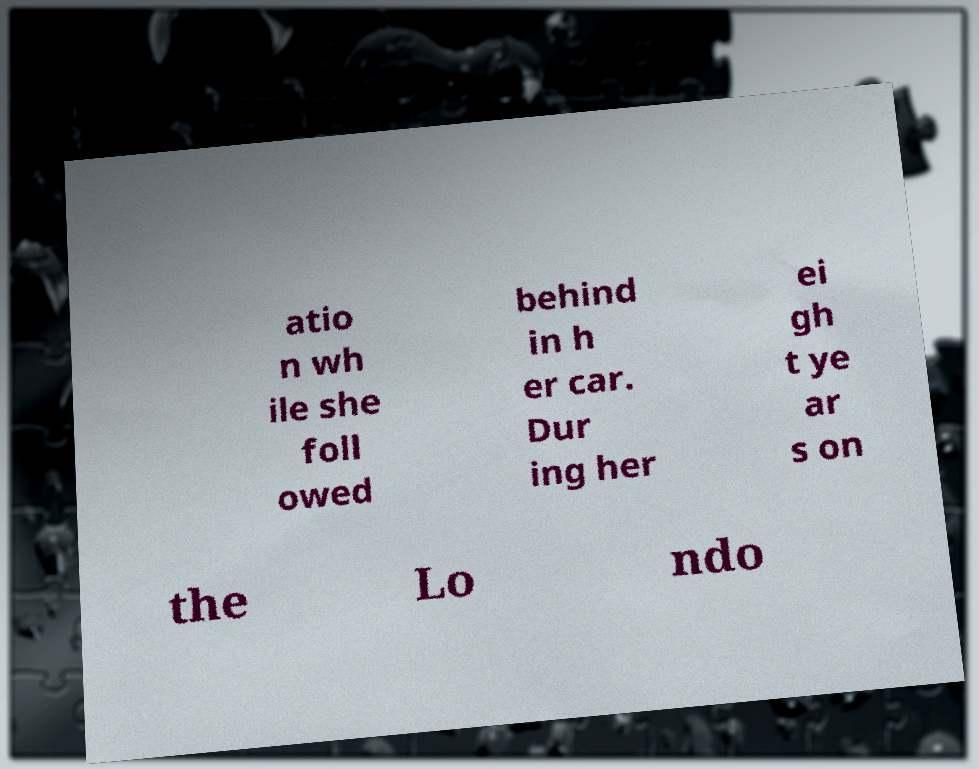Please read and relay the text visible in this image. What does it say? atio n wh ile she foll owed behind in h er car. Dur ing her ei gh t ye ar s on the Lo ndo 